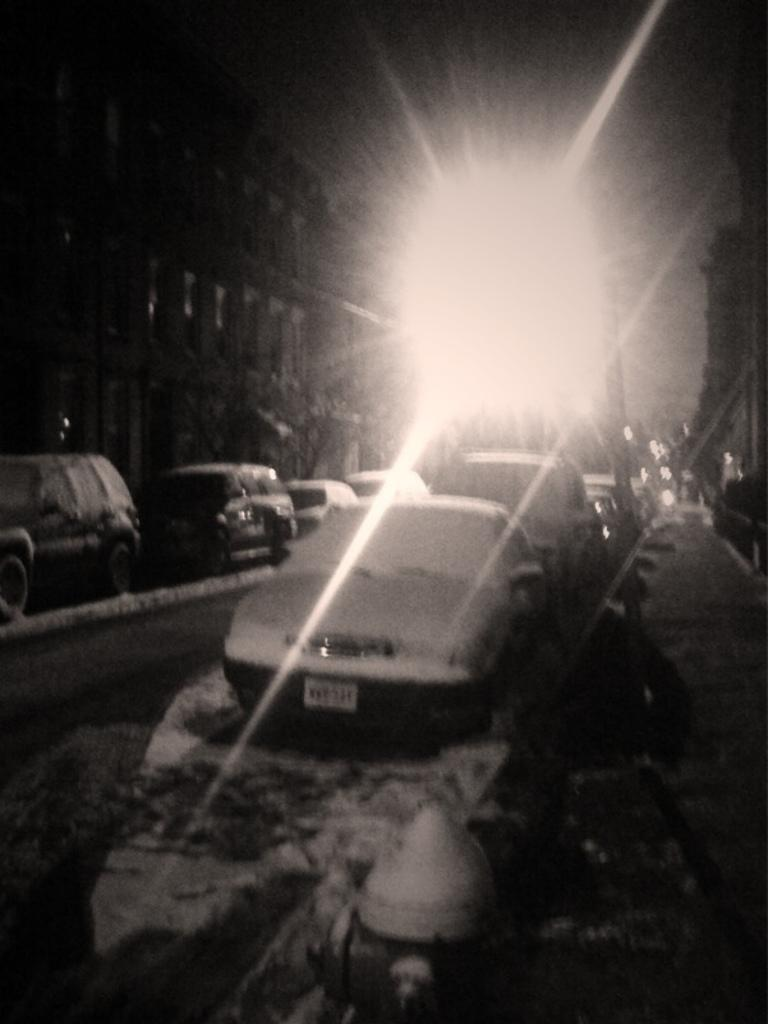What is the main feature of the image? There is a road in the image. What can be seen along the road? Some cars are parked on the roadside. How does the weather appear to be in the image? The parked cars are covered with snow, indicating that it is snowing or has recently snowed. What can be seen in the distance? There is a building visible in the background. What is the source of light at the top of the image? There is a light on top of the image, possibly a streetlight or a traffic light. Are there any airports visible in the image? There is no airport visible in the image; it primarily features a road, parked cars, and a building in the background. Are any of the people in the image wearing masks? There are no people visible in the image, so it is impossible to determine if anyone is wearing a mask. 